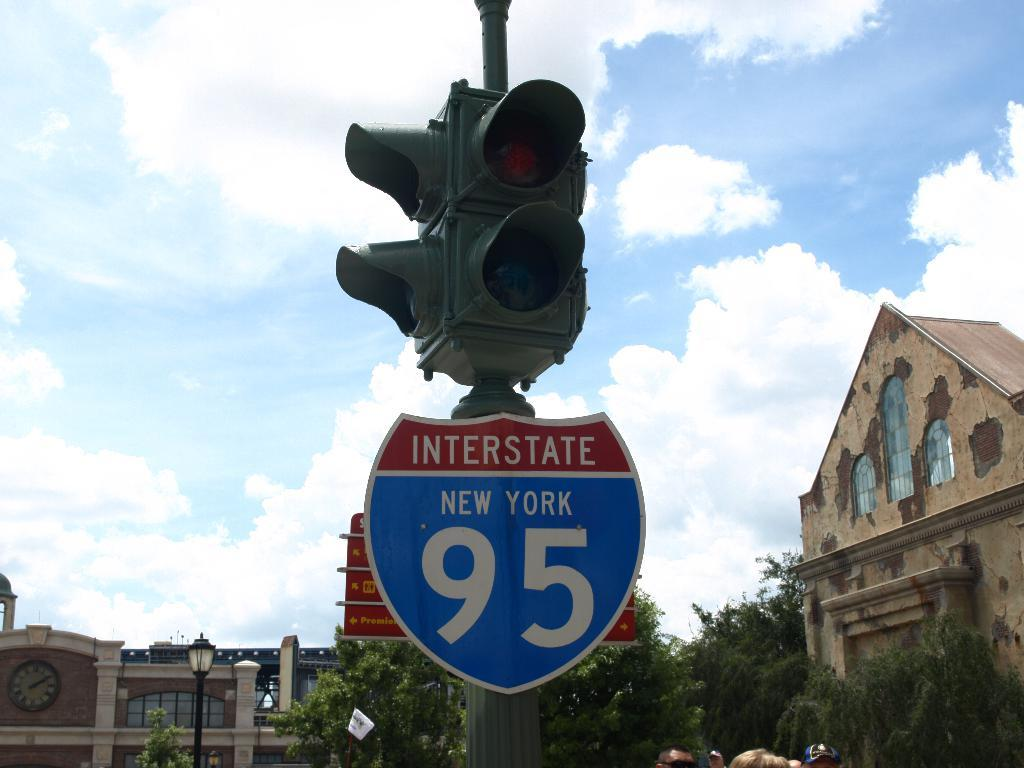Provide a one-sentence caption for the provided image. the number 95 on a sign that is below some lights. 